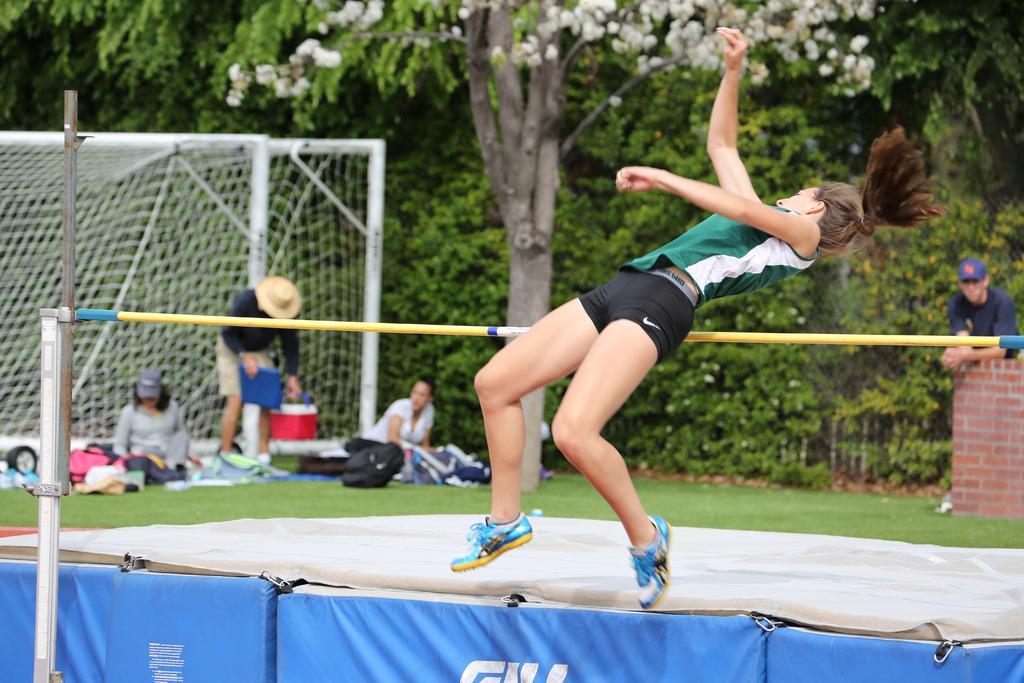Describe this image in one or two sentences. In this image, in the middle, we can see a woman jumping towards back side on the rod. On the right side, we can see a brick wall and a man standing in front of the brick wall. On the left side, we can see a group people, net fence. In the background, we can see some trees, flowers. At the bottom, we can see a stage and a grass. 